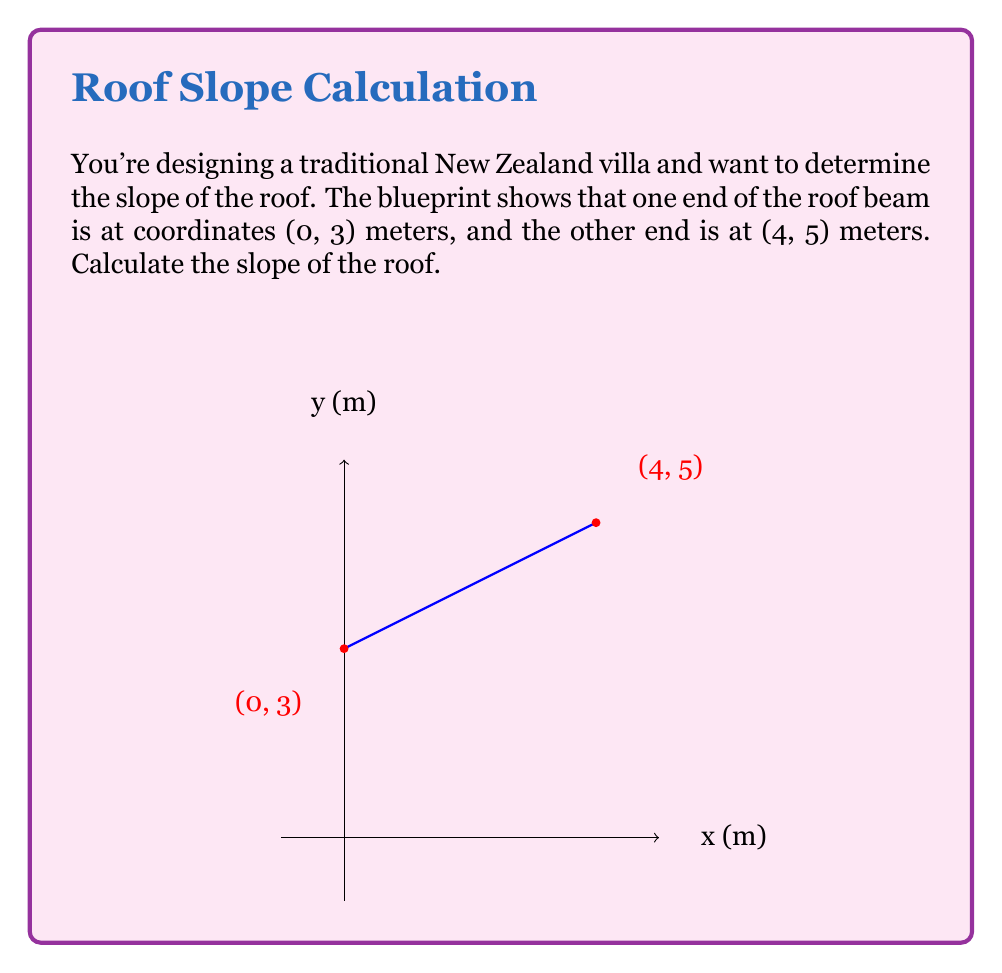Solve this math problem. To calculate the slope of the roof, we need to use the slope formula:

$$ \text{Slope} = \frac{\text{Rise}}{\text{Run}} = \frac{y_2 - y_1}{x_2 - x_1} $$

Where $(x_1, y_1)$ is the first point and $(x_2, y_2)$ is the second point.

Given:
- Point 1: $(0, 3)$
- Point 2: $(4, 5)$

Let's substitute these values into the slope formula:

$$ \text{Slope} = \frac{5 - 3}{4 - 0} = \frac{2}{4} $$

Simplify the fraction:

$$ \text{Slope} = \frac{1}{2} = 0.5 $$

This means that for every 1 unit of horizontal distance, the roof rises 0.5 units vertically.

In construction terms, this is often expressed as a ratio. We can write this as a rise:run ratio of 1:2, which means the roof rises 1 unit for every 2 units of horizontal distance.
Answer: The slope of the roof is $\frac{1}{2}$ or 0.5 